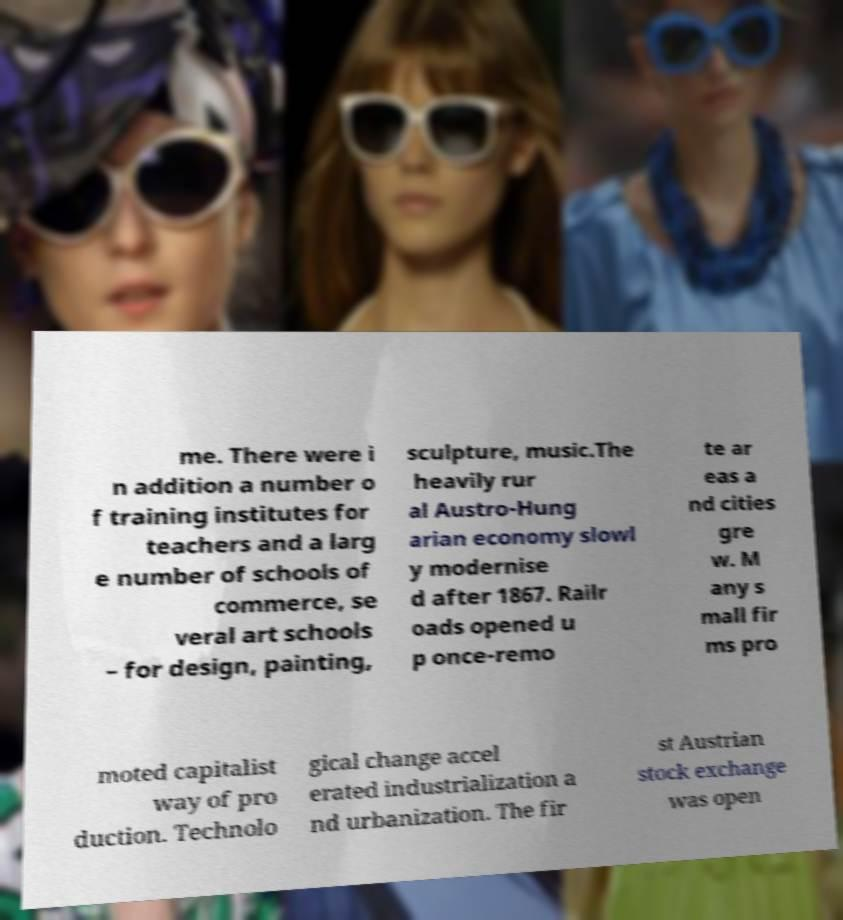What messages or text are displayed in this image? I need them in a readable, typed format. me. There were i n addition a number o f training institutes for teachers and a larg e number of schools of commerce, se veral art schools – for design, painting, sculpture, music.The heavily rur al Austro-Hung arian economy slowl y modernise d after 1867. Railr oads opened u p once-remo te ar eas a nd cities gre w. M any s mall fir ms pro moted capitalist way of pro duction. Technolo gical change accel erated industrialization a nd urbanization. The fir st Austrian stock exchange was open 